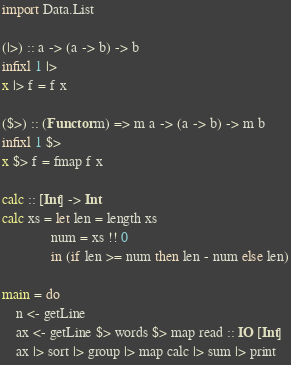<code> <loc_0><loc_0><loc_500><loc_500><_Haskell_>import Data.List

(|>) :: a -> (a -> b) -> b
infixl 1 |>
x |> f = f x

($>) :: (Functor m) => m a -> (a -> b) -> m b
infixl 1 $>
x $> f = fmap f x

calc :: [Int] -> Int
calc xs = let len = length xs
              num = xs !! 0
              in (if len >= num then len - num else len)

main = do
    n <- getLine
    ax <- getLine $> words $> map read :: IO [Int]
    ax |> sort |> group |> map calc |> sum |> print</code> 